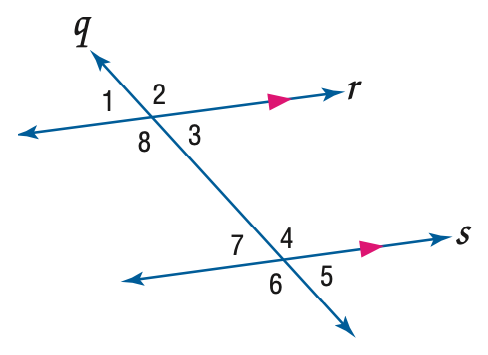Answer the mathemtical geometry problem and directly provide the correct option letter.
Question: Use the figure to find the indicated variable. Find y if m \angle 3 = 4 y + 30 and m \angle 7 = 7 y + 6.
Choices: A: 8 B: 9 C: 10 D: 12 A 